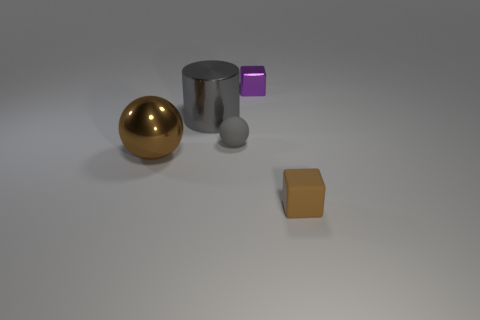What time of day or lighting setting does the image suggest? The image seems to be lit with an artificial, neutral light source, giving the impression of a controlled indoor setting, such as a studio, rather than a particular time of day. The shadows are soft and diffuse, indicative of a possibly overcast sky if outdoors or softbox lighting if indoors. 